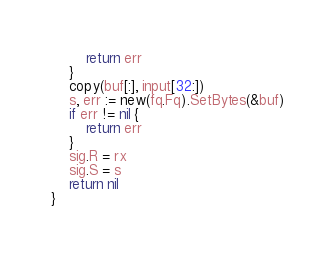Convert code to text. <code><loc_0><loc_0><loc_500><loc_500><_Go_>		return err
	}
	copy(buf[:], input[32:])
	s, err := new(fq.Fq).SetBytes(&buf)
	if err != nil {
		return err
	}
	sig.R = rx
	sig.S = s
	return nil
}
</code> 